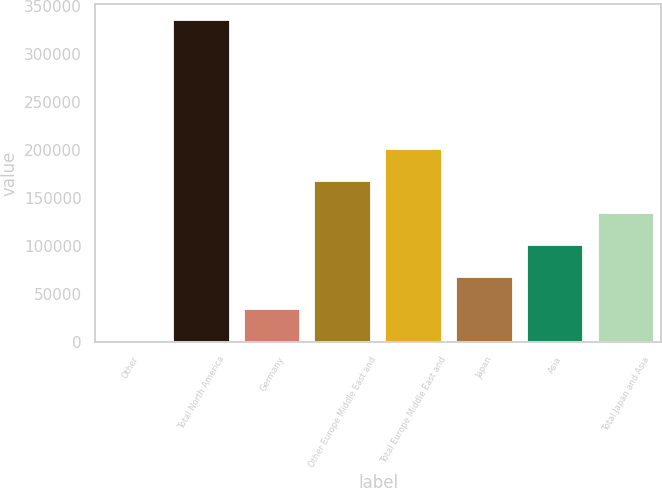<chart> <loc_0><loc_0><loc_500><loc_500><bar_chart><fcel>Other<fcel>Total North America<fcel>Germany<fcel>Other Europe Middle East and<fcel>Total Europe Middle East and<fcel>Japan<fcel>Asia<fcel>Total Japan and Asia<nl><fcel>371<fcel>335314<fcel>33865.3<fcel>167842<fcel>201337<fcel>67359.6<fcel>100854<fcel>134348<nl></chart> 